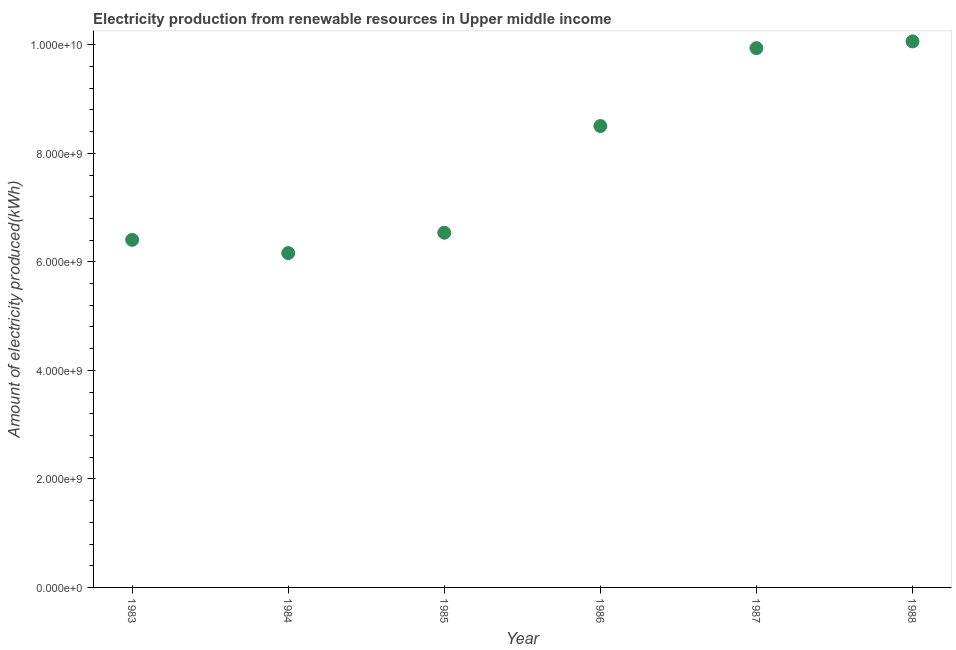What is the amount of electricity produced in 1983?
Keep it short and to the point. 6.41e+09. Across all years, what is the maximum amount of electricity produced?
Provide a short and direct response. 1.01e+1. Across all years, what is the minimum amount of electricity produced?
Provide a succinct answer. 6.16e+09. In which year was the amount of electricity produced maximum?
Your response must be concise. 1988. In which year was the amount of electricity produced minimum?
Offer a terse response. 1984. What is the sum of the amount of electricity produced?
Ensure brevity in your answer.  4.76e+1. What is the difference between the amount of electricity produced in 1983 and 1985?
Offer a very short reply. -1.31e+08. What is the average amount of electricity produced per year?
Provide a succinct answer. 7.94e+09. What is the median amount of electricity produced?
Your answer should be compact. 7.52e+09. What is the ratio of the amount of electricity produced in 1983 to that in 1984?
Keep it short and to the point. 1.04. Is the amount of electricity produced in 1983 less than that in 1987?
Ensure brevity in your answer.  Yes. Is the difference between the amount of electricity produced in 1985 and 1986 greater than the difference between any two years?
Offer a very short reply. No. What is the difference between the highest and the second highest amount of electricity produced?
Provide a short and direct response. 1.24e+08. Is the sum of the amount of electricity produced in 1983 and 1988 greater than the maximum amount of electricity produced across all years?
Give a very brief answer. Yes. What is the difference between the highest and the lowest amount of electricity produced?
Your response must be concise. 3.90e+09. How many dotlines are there?
Your answer should be compact. 1. How many years are there in the graph?
Keep it short and to the point. 6. What is the difference between two consecutive major ticks on the Y-axis?
Your answer should be very brief. 2.00e+09. Are the values on the major ticks of Y-axis written in scientific E-notation?
Ensure brevity in your answer.  Yes. Does the graph contain grids?
Offer a very short reply. No. What is the title of the graph?
Your answer should be compact. Electricity production from renewable resources in Upper middle income. What is the label or title of the X-axis?
Your response must be concise. Year. What is the label or title of the Y-axis?
Your response must be concise. Amount of electricity produced(kWh). What is the Amount of electricity produced(kWh) in 1983?
Make the answer very short. 6.41e+09. What is the Amount of electricity produced(kWh) in 1984?
Provide a succinct answer. 6.16e+09. What is the Amount of electricity produced(kWh) in 1985?
Offer a very short reply. 6.54e+09. What is the Amount of electricity produced(kWh) in 1986?
Your answer should be compact. 8.50e+09. What is the Amount of electricity produced(kWh) in 1987?
Offer a terse response. 9.94e+09. What is the Amount of electricity produced(kWh) in 1988?
Offer a very short reply. 1.01e+1. What is the difference between the Amount of electricity produced(kWh) in 1983 and 1984?
Make the answer very short. 2.44e+08. What is the difference between the Amount of electricity produced(kWh) in 1983 and 1985?
Give a very brief answer. -1.31e+08. What is the difference between the Amount of electricity produced(kWh) in 1983 and 1986?
Keep it short and to the point. -2.10e+09. What is the difference between the Amount of electricity produced(kWh) in 1983 and 1987?
Your answer should be very brief. -3.53e+09. What is the difference between the Amount of electricity produced(kWh) in 1983 and 1988?
Your answer should be compact. -3.66e+09. What is the difference between the Amount of electricity produced(kWh) in 1984 and 1985?
Ensure brevity in your answer.  -3.75e+08. What is the difference between the Amount of electricity produced(kWh) in 1984 and 1986?
Give a very brief answer. -2.34e+09. What is the difference between the Amount of electricity produced(kWh) in 1984 and 1987?
Your answer should be very brief. -3.78e+09. What is the difference between the Amount of electricity produced(kWh) in 1984 and 1988?
Provide a succinct answer. -3.90e+09. What is the difference between the Amount of electricity produced(kWh) in 1985 and 1986?
Your answer should be very brief. -1.97e+09. What is the difference between the Amount of electricity produced(kWh) in 1985 and 1987?
Give a very brief answer. -3.40e+09. What is the difference between the Amount of electricity produced(kWh) in 1985 and 1988?
Give a very brief answer. -3.53e+09. What is the difference between the Amount of electricity produced(kWh) in 1986 and 1987?
Your answer should be compact. -1.44e+09. What is the difference between the Amount of electricity produced(kWh) in 1986 and 1988?
Make the answer very short. -1.56e+09. What is the difference between the Amount of electricity produced(kWh) in 1987 and 1988?
Make the answer very short. -1.24e+08. What is the ratio of the Amount of electricity produced(kWh) in 1983 to that in 1984?
Offer a very short reply. 1.04. What is the ratio of the Amount of electricity produced(kWh) in 1983 to that in 1985?
Offer a very short reply. 0.98. What is the ratio of the Amount of electricity produced(kWh) in 1983 to that in 1986?
Offer a terse response. 0.75. What is the ratio of the Amount of electricity produced(kWh) in 1983 to that in 1987?
Ensure brevity in your answer.  0.65. What is the ratio of the Amount of electricity produced(kWh) in 1983 to that in 1988?
Offer a very short reply. 0.64. What is the ratio of the Amount of electricity produced(kWh) in 1984 to that in 1985?
Ensure brevity in your answer.  0.94. What is the ratio of the Amount of electricity produced(kWh) in 1984 to that in 1986?
Your answer should be very brief. 0.72. What is the ratio of the Amount of electricity produced(kWh) in 1984 to that in 1987?
Make the answer very short. 0.62. What is the ratio of the Amount of electricity produced(kWh) in 1984 to that in 1988?
Provide a succinct answer. 0.61. What is the ratio of the Amount of electricity produced(kWh) in 1985 to that in 1986?
Offer a terse response. 0.77. What is the ratio of the Amount of electricity produced(kWh) in 1985 to that in 1987?
Make the answer very short. 0.66. What is the ratio of the Amount of electricity produced(kWh) in 1985 to that in 1988?
Offer a very short reply. 0.65. What is the ratio of the Amount of electricity produced(kWh) in 1986 to that in 1987?
Give a very brief answer. 0.86. What is the ratio of the Amount of electricity produced(kWh) in 1986 to that in 1988?
Keep it short and to the point. 0.84. 